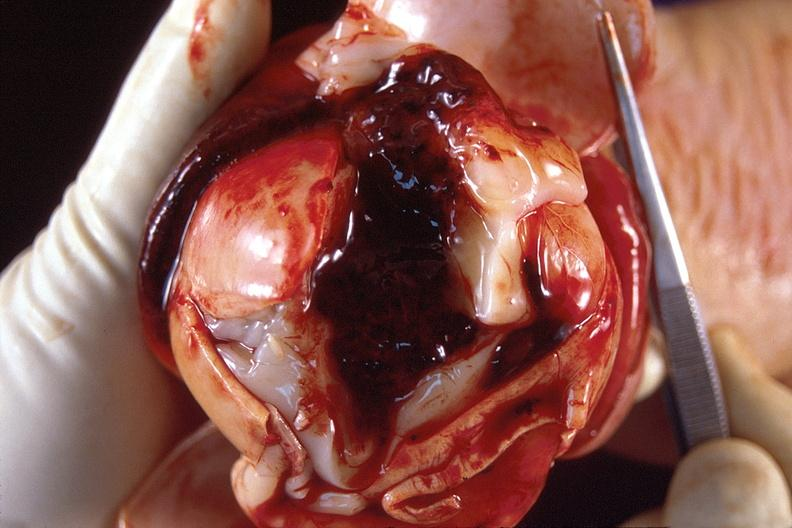what is present?
Answer the question using a single word or phrase. Nervous 